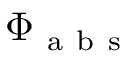<formula> <loc_0><loc_0><loc_500><loc_500>\Phi _ { a b s }</formula> 